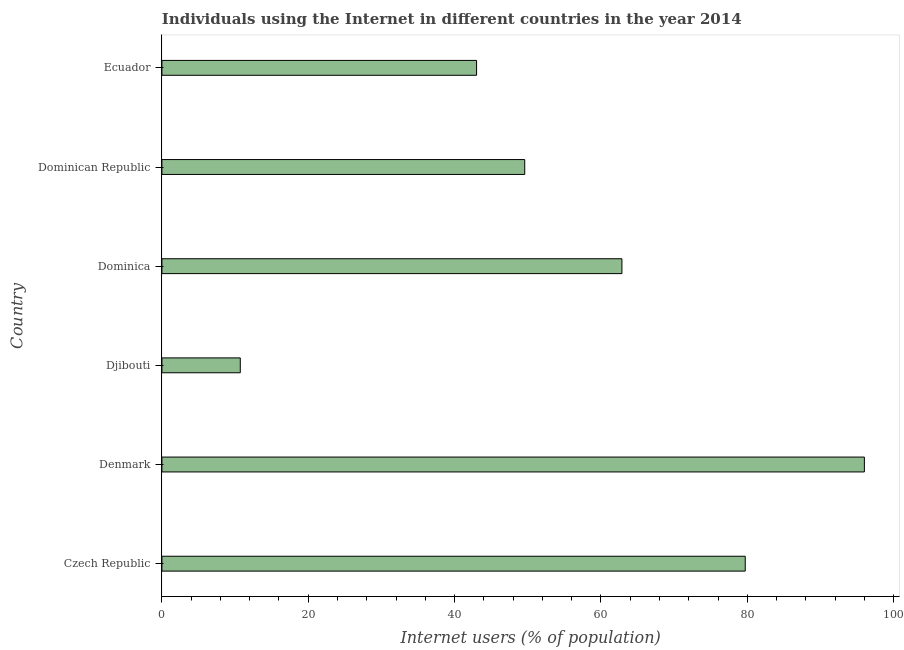What is the title of the graph?
Give a very brief answer. Individuals using the Internet in different countries in the year 2014. What is the label or title of the X-axis?
Your answer should be compact. Internet users (% of population). Across all countries, what is the maximum number of internet users?
Offer a terse response. 95.99. Across all countries, what is the minimum number of internet users?
Your answer should be very brief. 10.71. In which country was the number of internet users minimum?
Make the answer very short. Djibouti. What is the sum of the number of internet users?
Offer a very short reply. 341.85. What is the difference between the number of internet users in Czech Republic and Ecuador?
Offer a very short reply. 36.71. What is the average number of internet users per country?
Your answer should be compact. 56.98. What is the median number of internet users?
Provide a succinct answer. 56.22. In how many countries, is the number of internet users greater than 96 %?
Provide a succinct answer. 0. What is the ratio of the number of internet users in Denmark to that in Dominican Republic?
Offer a terse response. 1.94. What is the difference between the highest and the second highest number of internet users?
Your answer should be very brief. 16.28. What is the difference between the highest and the lowest number of internet users?
Provide a succinct answer. 85.28. How many bars are there?
Provide a succinct answer. 6. Are all the bars in the graph horizontal?
Give a very brief answer. Yes. How many countries are there in the graph?
Keep it short and to the point. 6. What is the difference between two consecutive major ticks on the X-axis?
Provide a short and direct response. 20. What is the Internet users (% of population) of Czech Republic?
Ensure brevity in your answer.  79.71. What is the Internet users (% of population) of Denmark?
Ensure brevity in your answer.  95.99. What is the Internet users (% of population) of Djibouti?
Your answer should be very brief. 10.71. What is the Internet users (% of population) in Dominica?
Give a very brief answer. 62.86. What is the Internet users (% of population) in Dominican Republic?
Offer a very short reply. 49.58. What is the Internet users (% of population) of Ecuador?
Keep it short and to the point. 43. What is the difference between the Internet users (% of population) in Czech Republic and Denmark?
Make the answer very short. -16.28. What is the difference between the Internet users (% of population) in Czech Republic and Dominica?
Give a very brief answer. 16.85. What is the difference between the Internet users (% of population) in Czech Republic and Dominican Republic?
Provide a short and direct response. 30.13. What is the difference between the Internet users (% of population) in Czech Republic and Ecuador?
Your answer should be very brief. 36.71. What is the difference between the Internet users (% of population) in Denmark and Djibouti?
Ensure brevity in your answer.  85.28. What is the difference between the Internet users (% of population) in Denmark and Dominica?
Make the answer very short. 33.13. What is the difference between the Internet users (% of population) in Denmark and Dominican Republic?
Your response must be concise. 46.41. What is the difference between the Internet users (% of population) in Denmark and Ecuador?
Your answer should be very brief. 52.99. What is the difference between the Internet users (% of population) in Djibouti and Dominica?
Provide a succinct answer. -52.15. What is the difference between the Internet users (% of population) in Djibouti and Dominican Republic?
Ensure brevity in your answer.  -38.87. What is the difference between the Internet users (% of population) in Djibouti and Ecuador?
Provide a succinct answer. -32.29. What is the difference between the Internet users (% of population) in Dominica and Dominican Republic?
Offer a very short reply. 13.28. What is the difference between the Internet users (% of population) in Dominica and Ecuador?
Make the answer very short. 19.86. What is the difference between the Internet users (% of population) in Dominican Republic and Ecuador?
Your answer should be compact. 6.58. What is the ratio of the Internet users (% of population) in Czech Republic to that in Denmark?
Ensure brevity in your answer.  0.83. What is the ratio of the Internet users (% of population) in Czech Republic to that in Djibouti?
Make the answer very short. 7.44. What is the ratio of the Internet users (% of population) in Czech Republic to that in Dominica?
Provide a succinct answer. 1.27. What is the ratio of the Internet users (% of population) in Czech Republic to that in Dominican Republic?
Your response must be concise. 1.61. What is the ratio of the Internet users (% of population) in Czech Republic to that in Ecuador?
Provide a succinct answer. 1.85. What is the ratio of the Internet users (% of population) in Denmark to that in Djibouti?
Your response must be concise. 8.96. What is the ratio of the Internet users (% of population) in Denmark to that in Dominica?
Provide a short and direct response. 1.53. What is the ratio of the Internet users (% of population) in Denmark to that in Dominican Republic?
Offer a very short reply. 1.94. What is the ratio of the Internet users (% of population) in Denmark to that in Ecuador?
Provide a short and direct response. 2.23. What is the ratio of the Internet users (% of population) in Djibouti to that in Dominica?
Keep it short and to the point. 0.17. What is the ratio of the Internet users (% of population) in Djibouti to that in Dominican Republic?
Ensure brevity in your answer.  0.22. What is the ratio of the Internet users (% of population) in Djibouti to that in Ecuador?
Make the answer very short. 0.25. What is the ratio of the Internet users (% of population) in Dominica to that in Dominican Republic?
Your answer should be compact. 1.27. What is the ratio of the Internet users (% of population) in Dominica to that in Ecuador?
Your answer should be very brief. 1.46. What is the ratio of the Internet users (% of population) in Dominican Republic to that in Ecuador?
Make the answer very short. 1.15. 